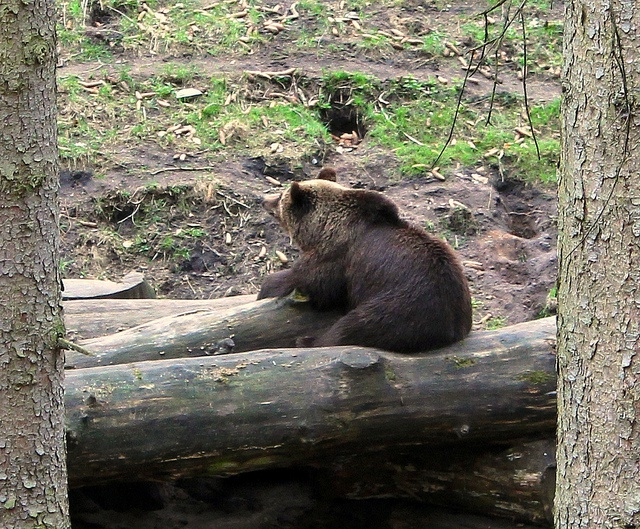Describe the objects in this image and their specific colors. I can see a bear in tan, black, and gray tones in this image. 